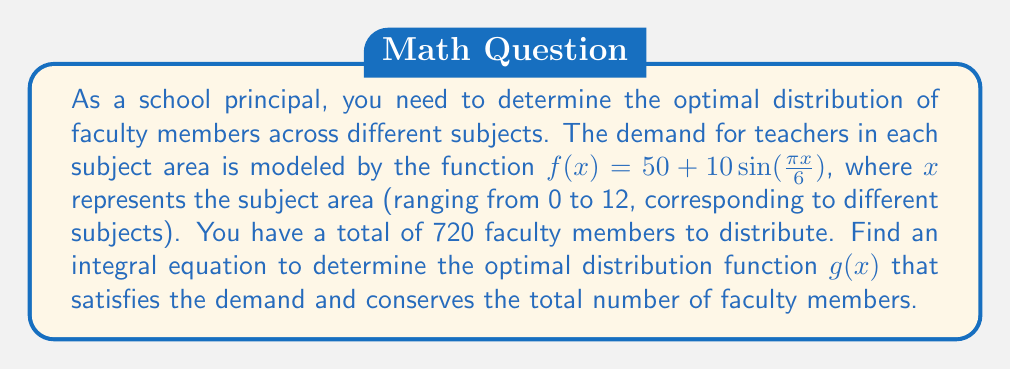Help me with this question. To solve this problem, we need to follow these steps:

1. Understand the given information:
   - Demand function: $f(x) = 50 + 10\sin(\frac{\pi x}{6})$
   - Subject range: $0 \leq x \leq 12$
   - Total faculty members: 720

2. Set up the integral equation:
   The distribution function $g(x)$ should satisfy two conditions:
   
   a) It should meet or exceed the demand: $g(x) \geq f(x)$ for all $x$
   b) The total number of faculty members should equal 720:
      $$\int_0^{12} g(x) dx = 720$$

3. Optimize the distribution:
   To minimize excess faculty, we want $g(x)$ to be as close to $f(x)$ as possible while still meeting the demand. Therefore, we can set:
   $$g(x) = f(x) + c$$
   where $c$ is a constant to be determined.

4. Substitute into the integral equation:
   $$\int_0^{12} (f(x) + c) dx = 720$$

5. Expand the integral:
   $$\int_0^{12} f(x) dx + \int_0^{12} c dx = 720$$

6. Solve for $c$:
   $$\int_0^{12} (50 + 10\sin(\frac{\pi x}{6})) dx + 12c = 720$$
   $$[50x - \frac{60}{\pi}\cos(\frac{\pi x}{6})]_0^{12} + 12c = 720$$
   $$600 - \frac{60}{\pi}(\cos(2\pi) - 1) + 12c = 720$$
   $$600 + 12c = 720$$
   $$12c = 120$$
   $$c = 10$$

7. Therefore, the optimal distribution function is:
   $$g(x) = 60 + 10\sin(\frac{\pi x}{6})$$

This function ensures that the demand is met for all subject areas and that exactly 720 faculty members are distributed.
Answer: $g(x) = 60 + 10\sin(\frac{\pi x}{6})$ 